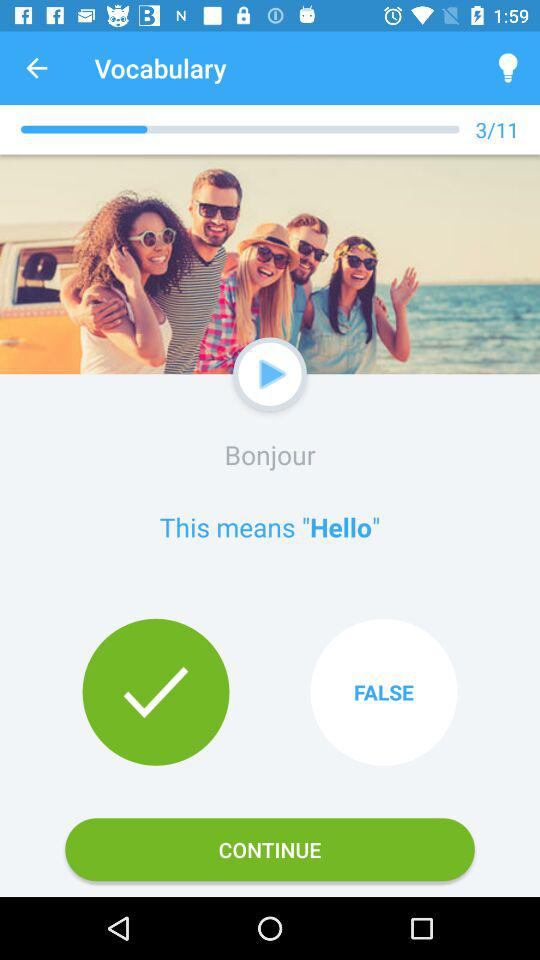What does "Bonjour" mean?
Answer the question using a single word or phrase. "Bonjour" means "Hello". 